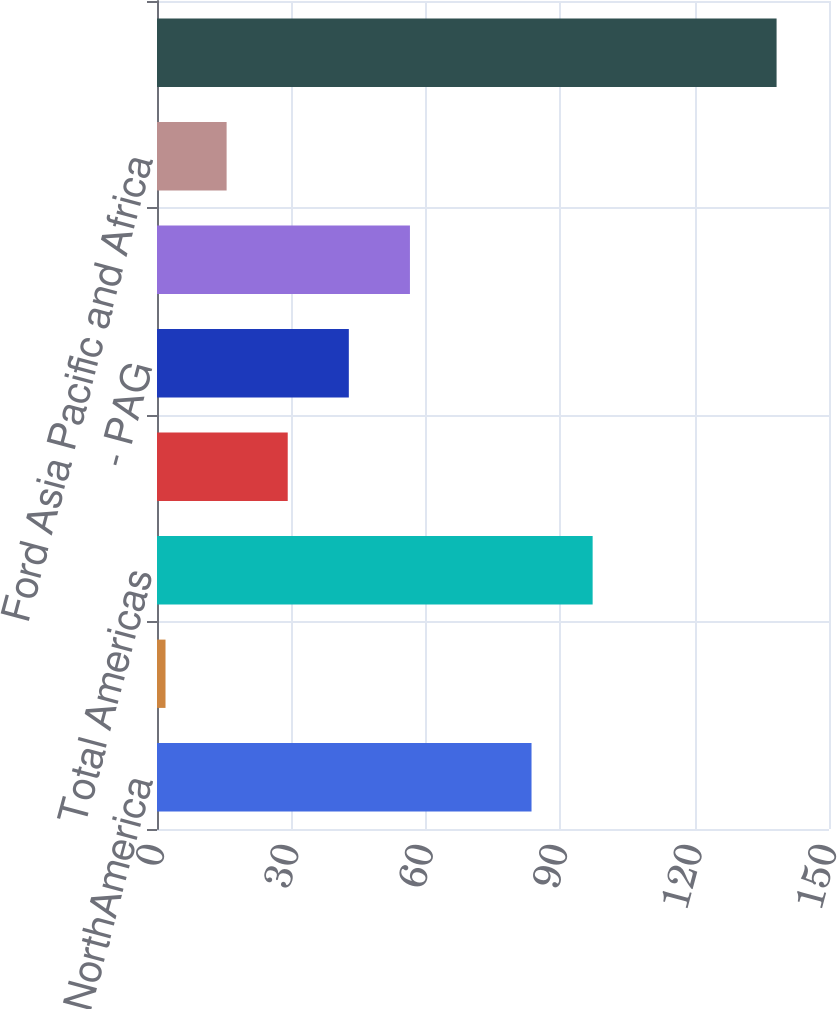Convert chart to OTSL. <chart><loc_0><loc_0><loc_500><loc_500><bar_chart><fcel>- Ford NorthAmerica<fcel>- Ford South America<fcel>Total Americas<fcel>- Ford Europe<fcel>- PAG<fcel>Total Ford Europe and PAG<fcel>Ford Asia Pacific and Africa<fcel>Total Automotive<nl><fcel>83.6<fcel>1.9<fcel>97.24<fcel>29.18<fcel>42.82<fcel>56.46<fcel>15.54<fcel>138.3<nl></chart> 